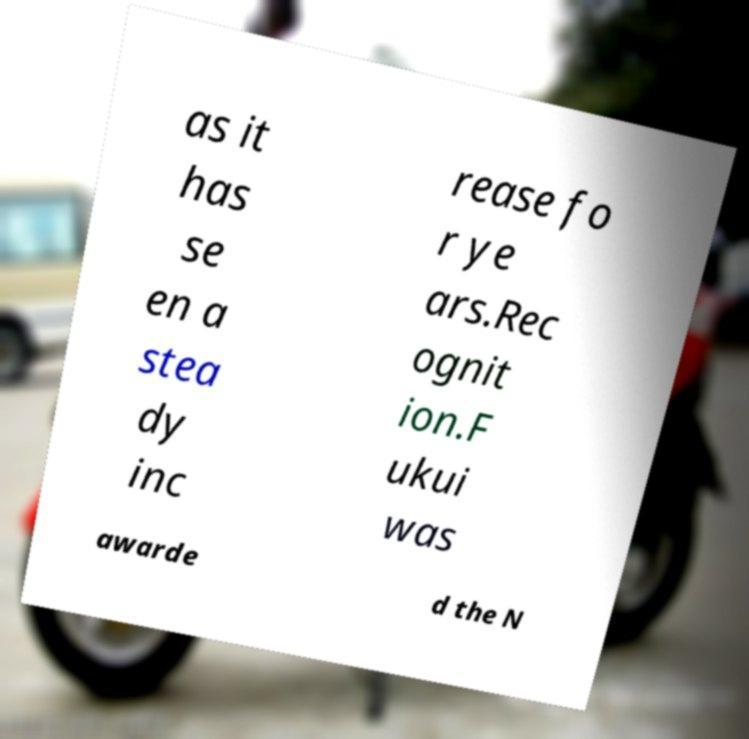I need the written content from this picture converted into text. Can you do that? as it has se en a stea dy inc rease fo r ye ars.Rec ognit ion.F ukui was awarde d the N 